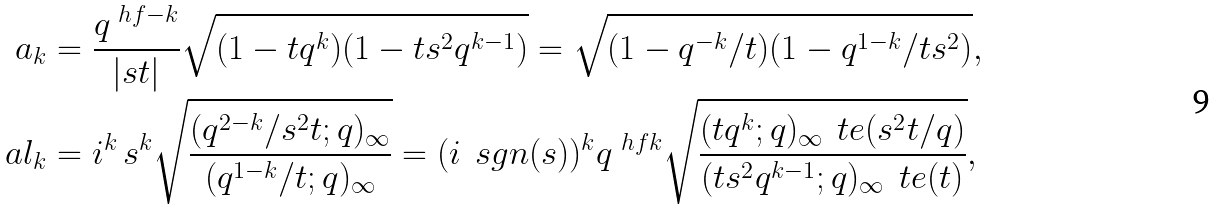Convert formula to latex. <formula><loc_0><loc_0><loc_500><loc_500>a _ { k } & = \frac { q ^ { \ h f - k } } { | s t | } \sqrt { ( 1 - t q ^ { k } ) ( 1 - t s ^ { 2 } q ^ { k - 1 } ) } = \sqrt { ( 1 - q ^ { - k } / t ) ( 1 - q ^ { 1 - k } / t s ^ { 2 } ) } , \\ \ a l _ { k } & = i ^ { k } \, s ^ { k } \sqrt { \frac { ( q ^ { 2 - k } / s ^ { 2 } t ; q ) _ { \infty } } { ( q ^ { 1 - k } / t ; q ) _ { \infty } } } = ( i \, \ s g n ( s ) ) ^ { k } q ^ { \ h f k } \sqrt { \frac { ( t q ^ { k } ; q ) _ { \infty } \, \ t e ( s ^ { 2 } t / q ) } { ( t s ^ { 2 } q ^ { k - 1 } ; q ) _ { \infty } \, \ t e ( t ) } } ,</formula> 